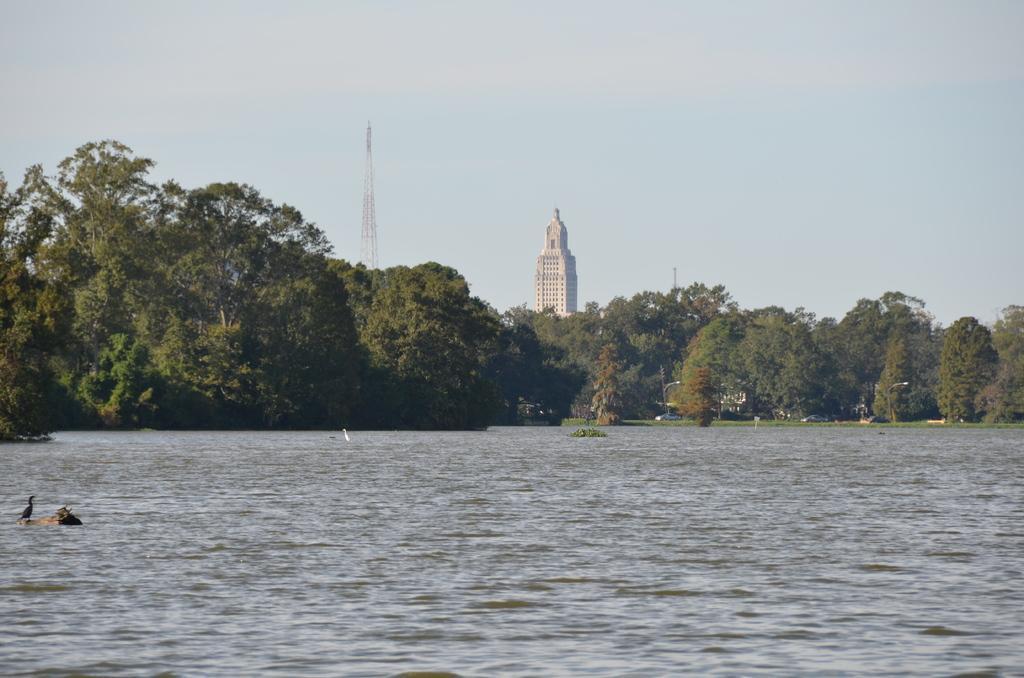How would you summarize this image in a sentence or two? In this picture there is water at the bottom side of the image and there are trees in the center of the image, there is a skyscraper and a radio tower in the background area of the image and there is a bird on the rock on the left side of the image. 